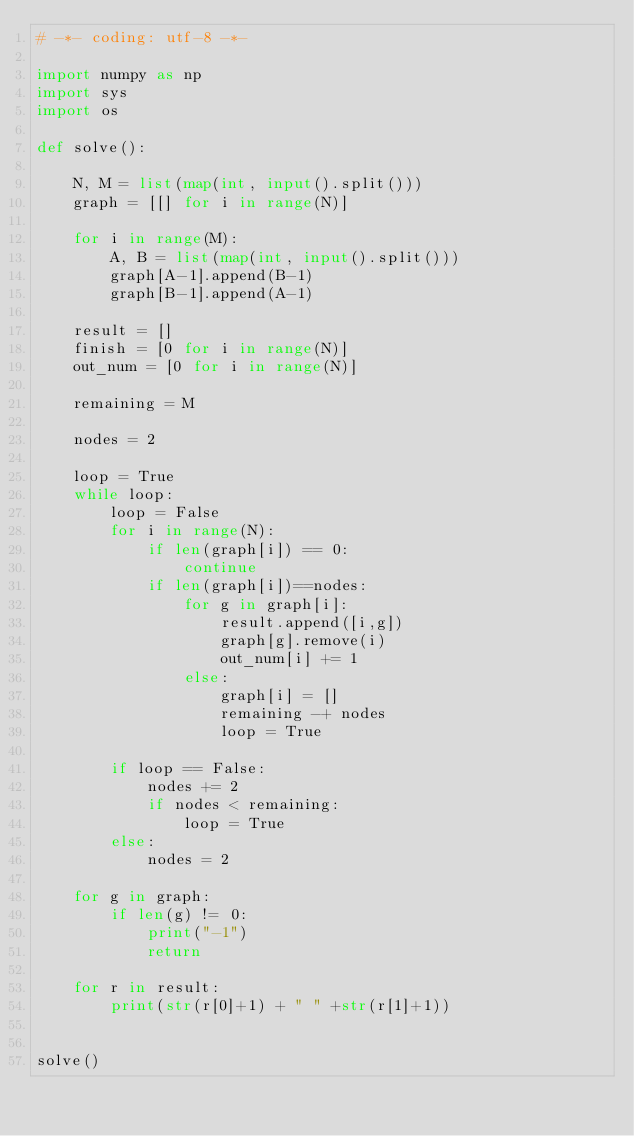<code> <loc_0><loc_0><loc_500><loc_500><_Python_># -*- coding: utf-8 -*-

import numpy as np
import sys
import os

def solve():

    N, M = list(map(int, input().split()))
    graph = [[] for i in range(N)]

    for i in range(M):
        A, B = list(map(int, input().split()))
        graph[A-1].append(B-1)
        graph[B-1].append(A-1)

    result = []
    finish = [0 for i in range(N)]
    out_num = [0 for i in range(N)]

    remaining = M

    nodes = 2

    loop = True
    while loop:
        loop = False
        for i in range(N):
            if len(graph[i]) == 0:
                continue
            if len(graph[i])==nodes:
                for g in graph[i]:
                    result.append([i,g])
                    graph[g].remove(i)
                    out_num[i] += 1
                else:
                    graph[i] = []
                    remaining -+ nodes
                    loop = True

        if loop == False:
            nodes += 2
            if nodes < remaining:
                loop = True
        else:
            nodes = 2

    for g in graph:
        if len(g) != 0:
            print("-1")
            return

    for r in result:
        print(str(r[0]+1) + " " +str(r[1]+1))


solve()
</code> 